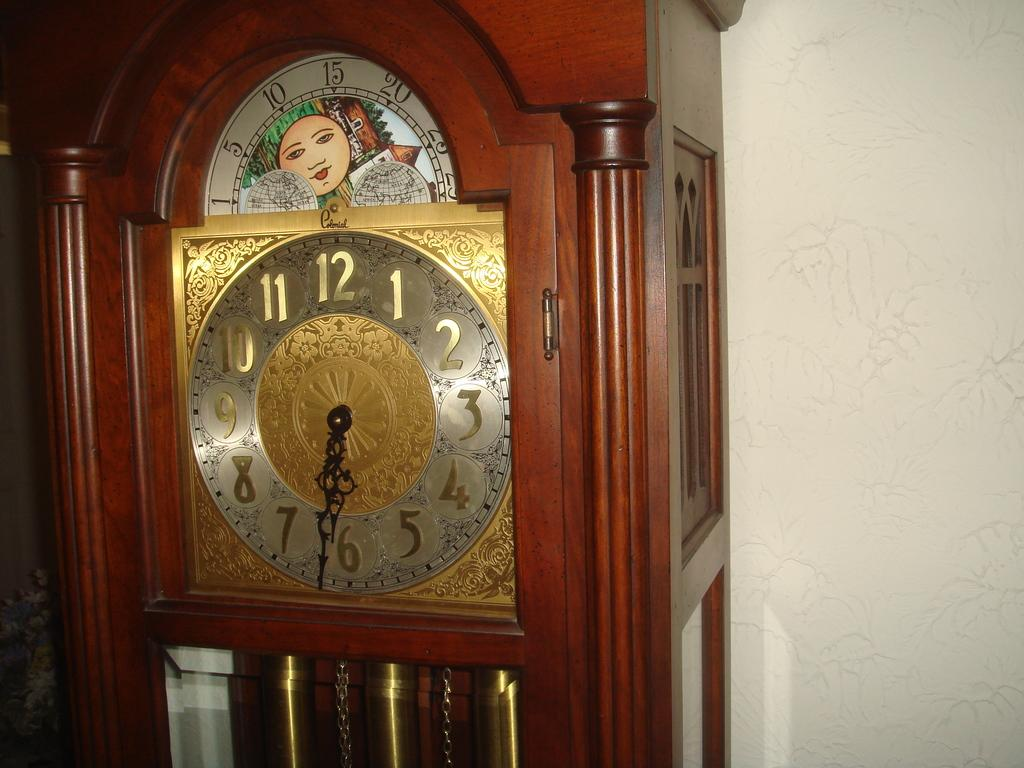<image>
Present a compact description of the photo's key features. The grandfather clock with a gold face has the time of 6:32. 